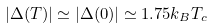Convert formula to latex. <formula><loc_0><loc_0><loc_500><loc_500>| \Delta ( T ) | \simeq | \Delta ( 0 ) | \simeq 1 . 7 5 k _ { B } T _ { c }</formula> 